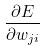<formula> <loc_0><loc_0><loc_500><loc_500>\frac { \partial E } { \partial w _ { j i } }</formula> 